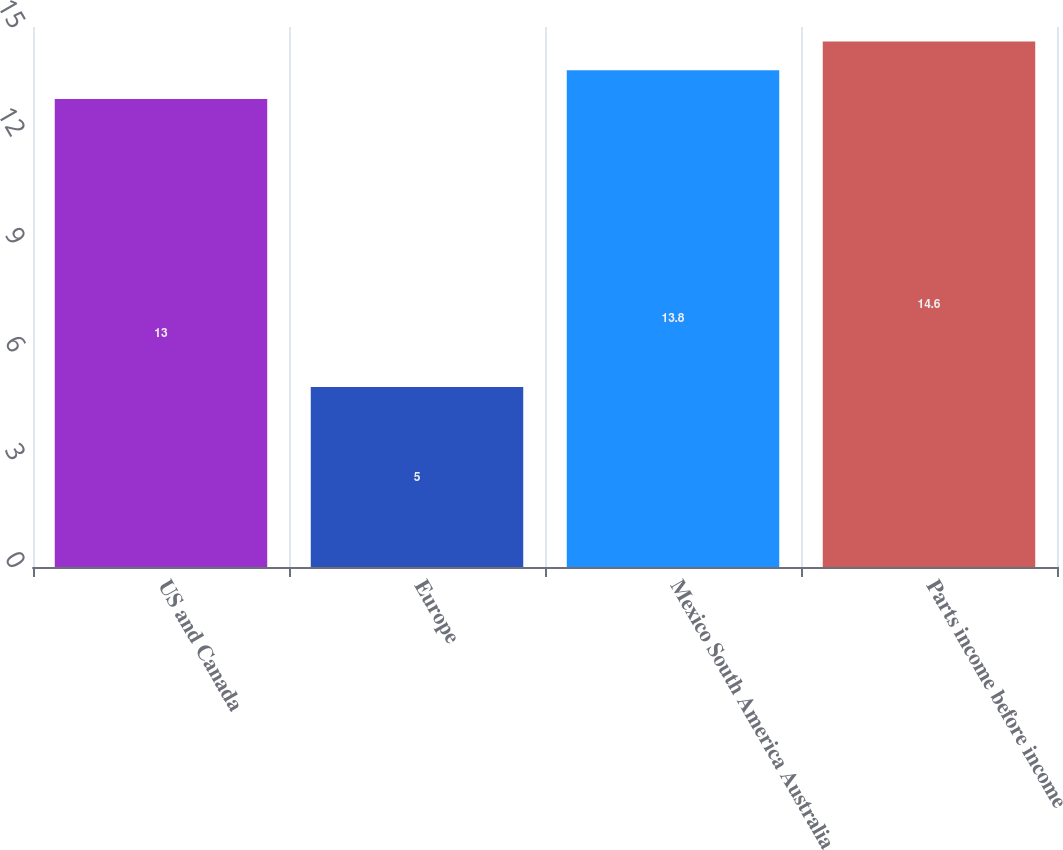<chart> <loc_0><loc_0><loc_500><loc_500><bar_chart><fcel>US and Canada<fcel>Europe<fcel>Mexico South America Australia<fcel>Parts income before income<nl><fcel>13<fcel>5<fcel>13.8<fcel>14.6<nl></chart> 